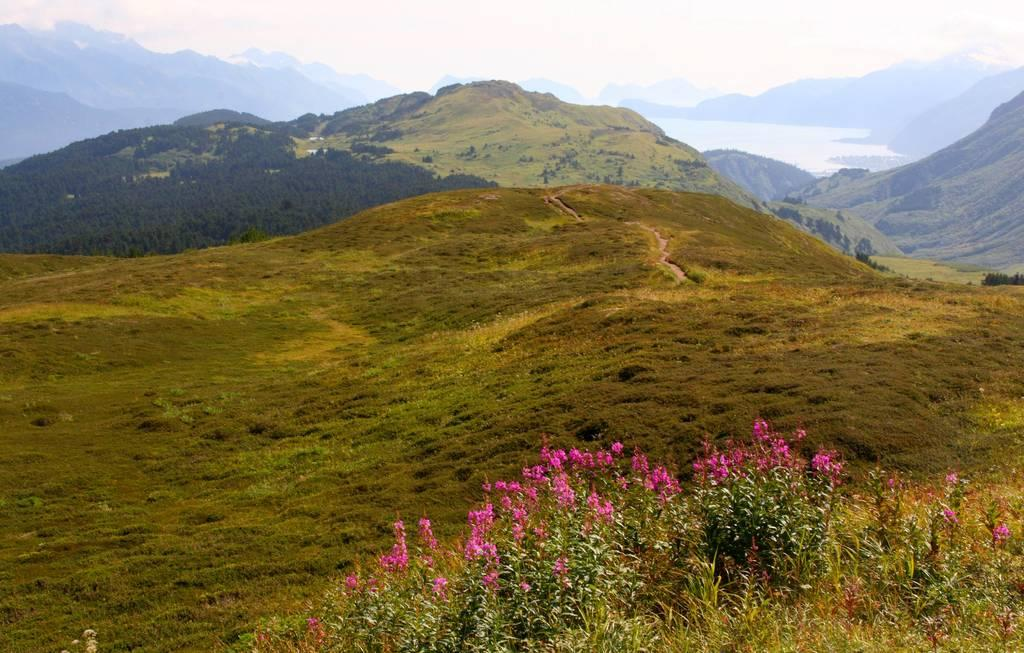What geographical feature is located in the middle of the image? There are hills in the middle of the image. What can be found on the hills? There are plants and flowers on the hills. What is visible at the top of the image? There are clouds visible at the top of the image. Where are the clouds located? The clouds are in the sky. What type of wood is being used for driving in the image? There is no wood or driving present in the image. 